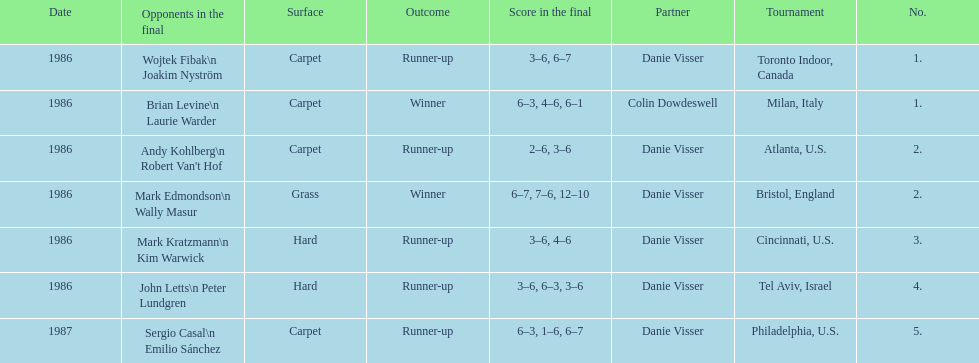Who is the last partner listed? Danie Visser. 